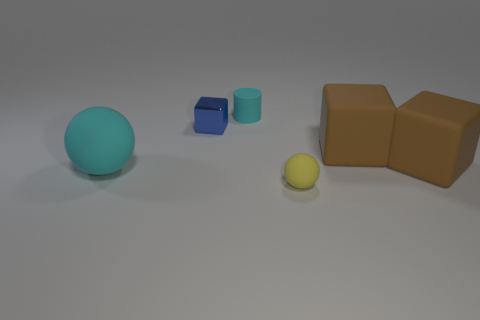Subtract all blue blocks. How many blocks are left? 2 Subtract all blue blocks. How many blocks are left? 2 Subtract all balls. How many objects are left? 4 Subtract 2 balls. How many balls are left? 0 Add 4 small blue blocks. How many small blue blocks are left? 5 Add 5 large brown cubes. How many large brown cubes exist? 7 Add 4 purple metallic cylinders. How many objects exist? 10 Subtract 0 green blocks. How many objects are left? 6 Subtract all purple balls. Subtract all brown cubes. How many balls are left? 2 Subtract all purple cylinders. How many brown cubes are left? 2 